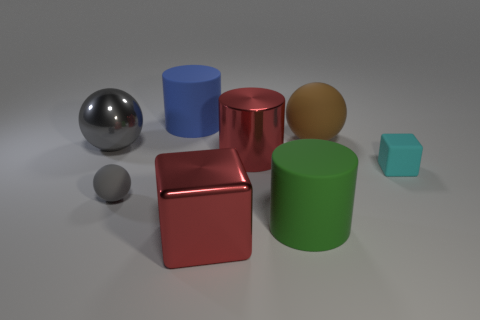There is a gray sphere that is the same size as the brown matte thing; what is it made of?
Offer a terse response. Metal. How many other things are there of the same color as the large matte sphere?
Your answer should be compact. 0. What is the shape of the red object that is in front of the cyan matte object?
Your response must be concise. Cube. Are there fewer green matte cylinders than small yellow matte objects?
Make the answer very short. No. Does the gray ball right of the metal sphere have the same material as the green cylinder?
Your response must be concise. Yes. Are there any large cylinders in front of the small cyan cube?
Offer a very short reply. Yes. There is a rubber cylinder in front of the big sphere on the left side of the large red metal thing that is in front of the red cylinder; what color is it?
Your response must be concise. Green. There is a brown matte thing that is the same size as the green thing; what is its shape?
Give a very brief answer. Sphere. Is the number of green cylinders greater than the number of tiny brown matte things?
Provide a short and direct response. Yes. Are there any matte balls left of the blue cylinder behind the cyan matte block?
Ensure brevity in your answer.  Yes. 